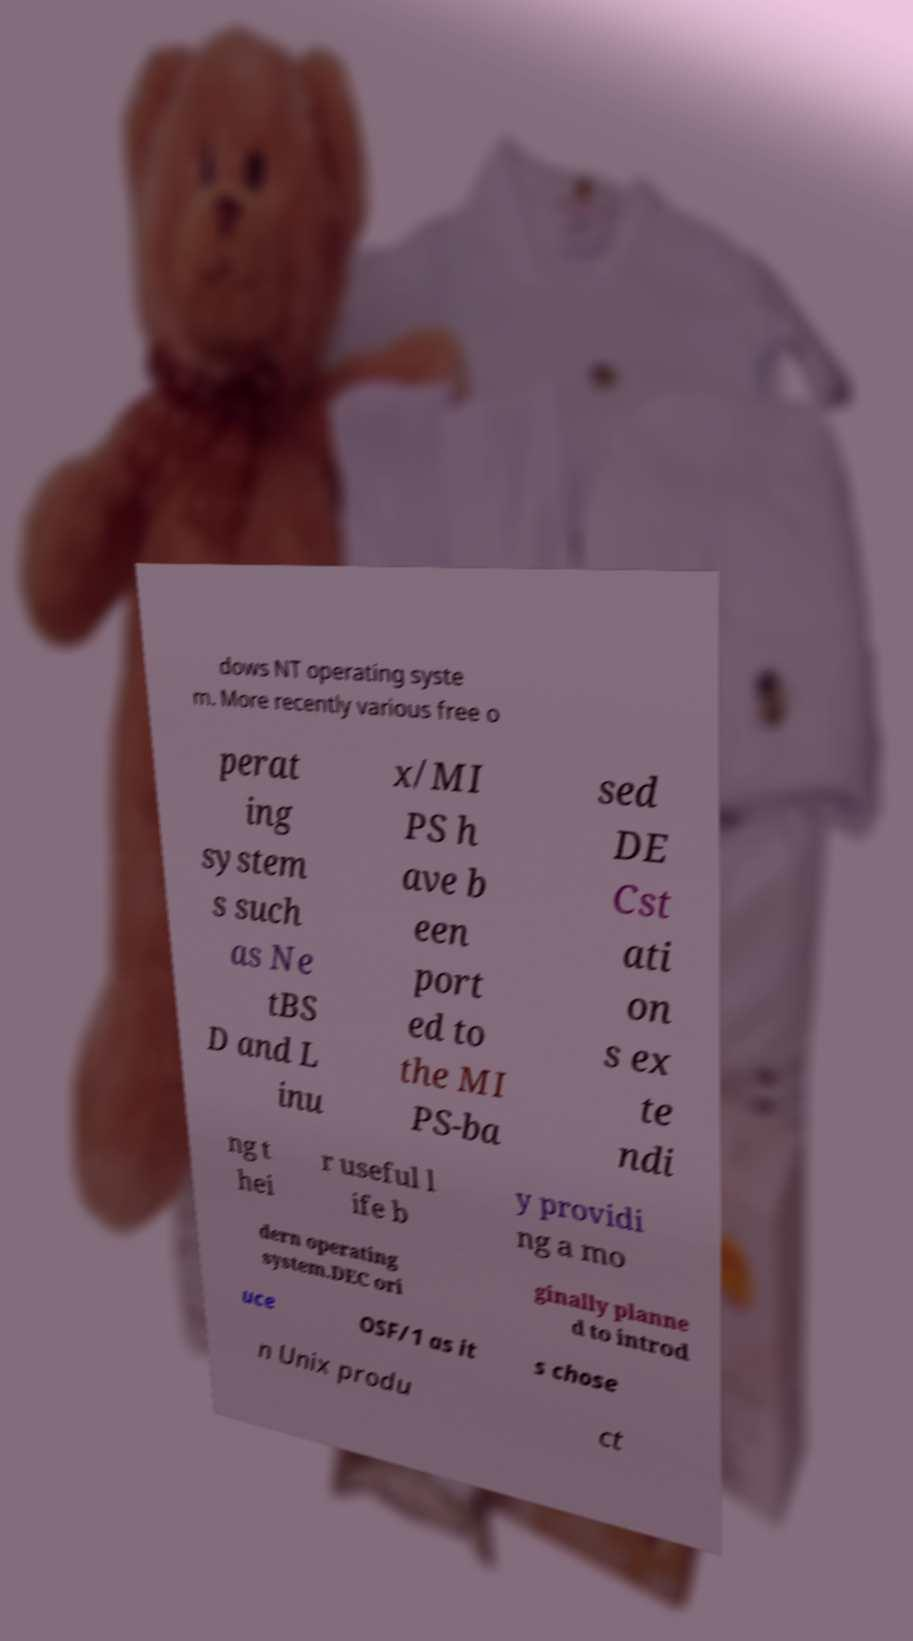Please read and relay the text visible in this image. What does it say? dows NT operating syste m. More recently various free o perat ing system s such as Ne tBS D and L inu x/MI PS h ave b een port ed to the MI PS-ba sed DE Cst ati on s ex te ndi ng t hei r useful l ife b y providi ng a mo dern operating system.DEC ori ginally planne d to introd uce OSF/1 as it s chose n Unix produ ct 